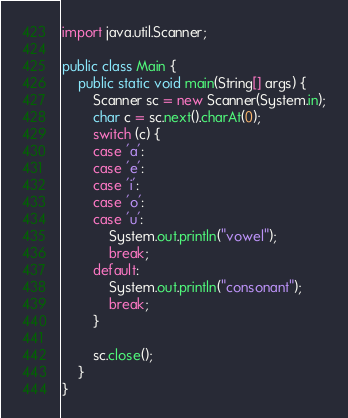Convert code to text. <code><loc_0><loc_0><loc_500><loc_500><_Java_>import java.util.Scanner;
 
public class Main {
	public static void main(String[] args) {
		Scanner sc = new Scanner(System.in);
		char c = sc.next().charAt(0);
		switch (c) {
		case 'a':
		case 'e':
		case 'i':
		case 'o':
		case 'u':
			System.out.println("vowel");
			break;
		default:
			System.out.println("consonant");
			break;
		}
		
		sc.close();
	}
}

</code> 